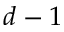<formula> <loc_0><loc_0><loc_500><loc_500>d - 1</formula> 